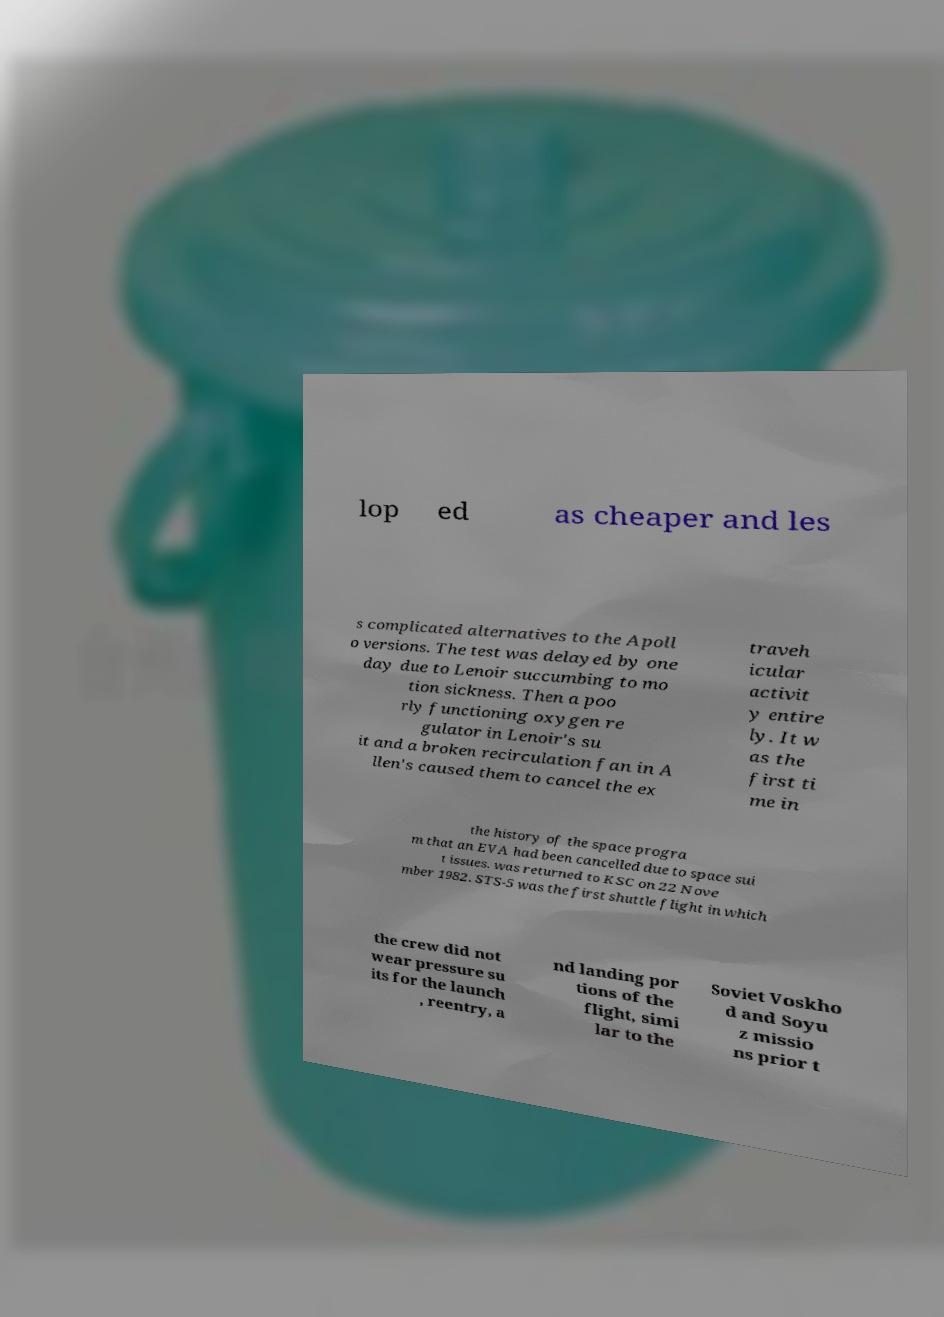Can you read and provide the text displayed in the image?This photo seems to have some interesting text. Can you extract and type it out for me? lop ed as cheaper and les s complicated alternatives to the Apoll o versions. The test was delayed by one day due to Lenoir succumbing to mo tion sickness. Then a poo rly functioning oxygen re gulator in Lenoir's su it and a broken recirculation fan in A llen's caused them to cancel the ex traveh icular activit y entire ly. It w as the first ti me in the history of the space progra m that an EVA had been cancelled due to space sui t issues. was returned to KSC on 22 Nove mber 1982. STS-5 was the first shuttle flight in which the crew did not wear pressure su its for the launch , reentry, a nd landing por tions of the flight, simi lar to the Soviet Voskho d and Soyu z missio ns prior t 